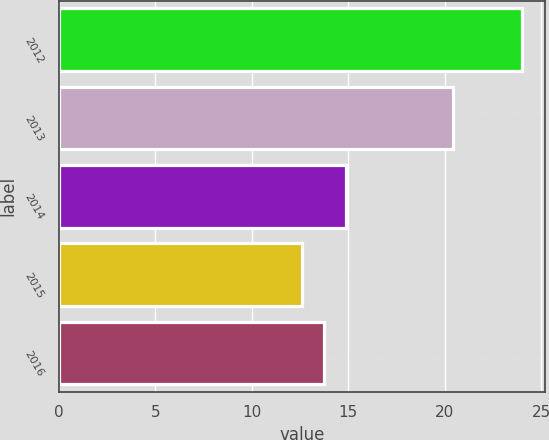Convert chart to OTSL. <chart><loc_0><loc_0><loc_500><loc_500><bar_chart><fcel>2012<fcel>2013<fcel>2014<fcel>2015<fcel>2016<nl><fcel>24<fcel>20.4<fcel>14.9<fcel>12.6<fcel>13.74<nl></chart> 